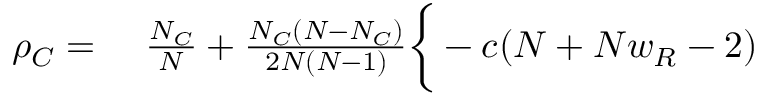<formula> <loc_0><loc_0><loc_500><loc_500>\begin{array} { r l } { \rho _ { C } = } & \frac { N _ { C } } { N } + \frac { N _ { C } ( N - N _ { C } ) } { 2 N ( N - 1 ) } \Big \{ - c ( N + N w _ { R } - 2 ) } \end{array}</formula> 